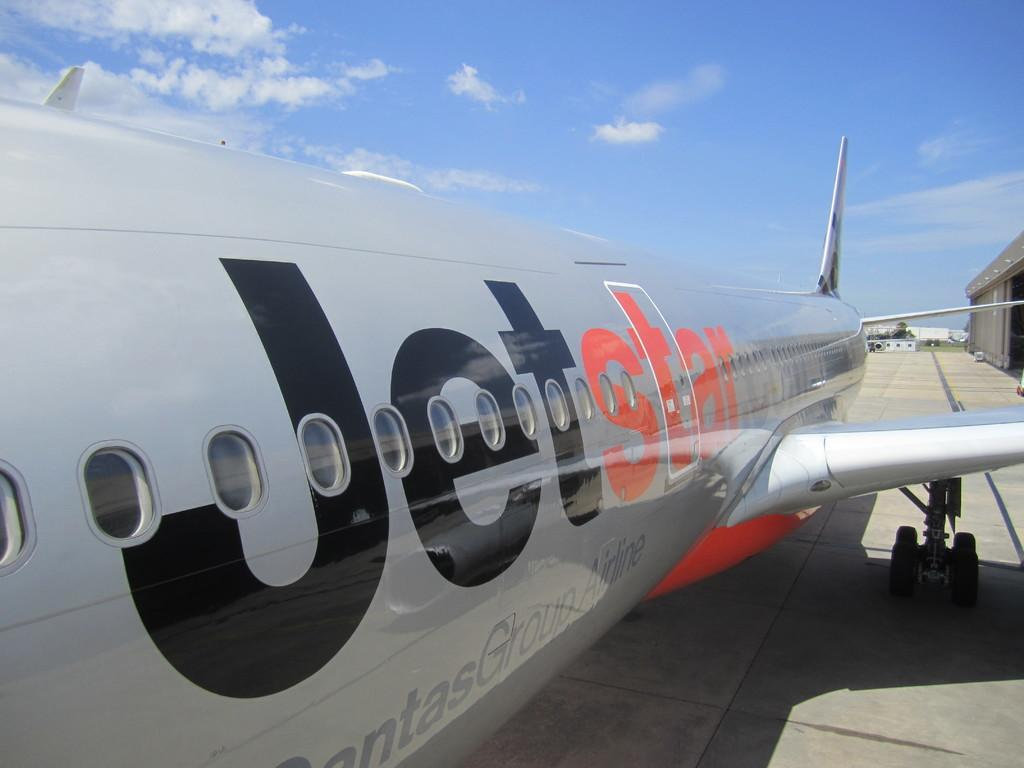<image>
Share a concise interpretation of the image provided. A view of the side of a silver Jetstar airplane. 